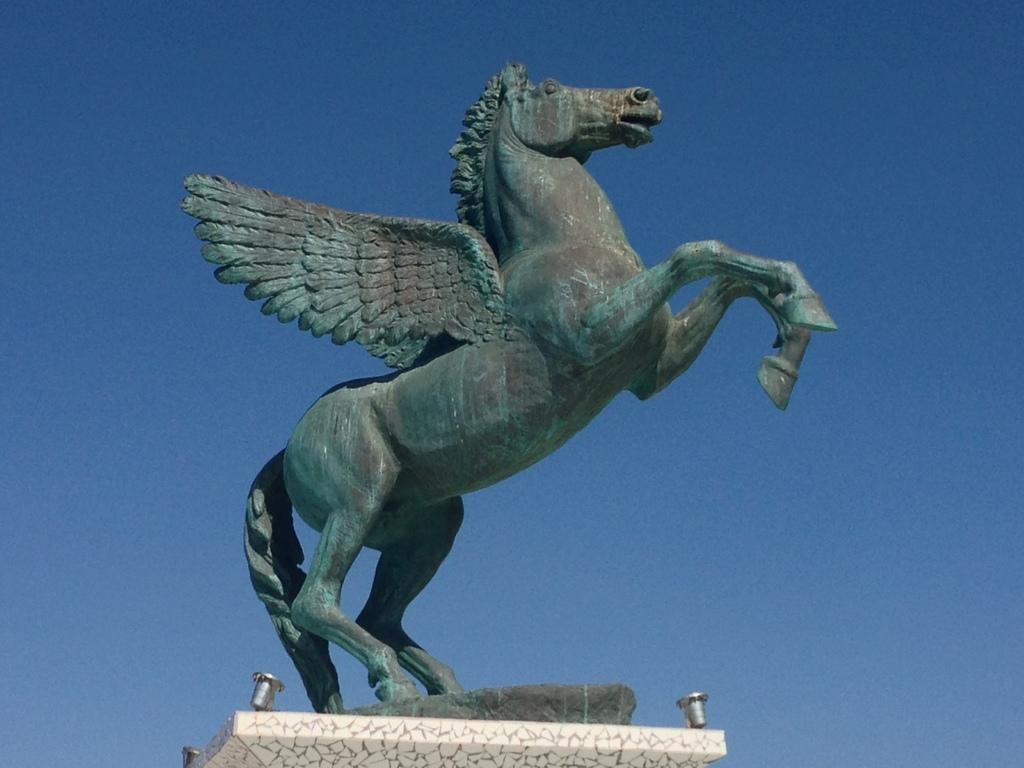What is there is a statue in the image, what can you tell me about it? There is a statue in the image, but no specific details about its appearance or subject are provided. What can be seen in the background of the image? The sky is visible in the background of the image. What is the name of the person being born in the image? There is no indication of a birth or a person being born in the image. 